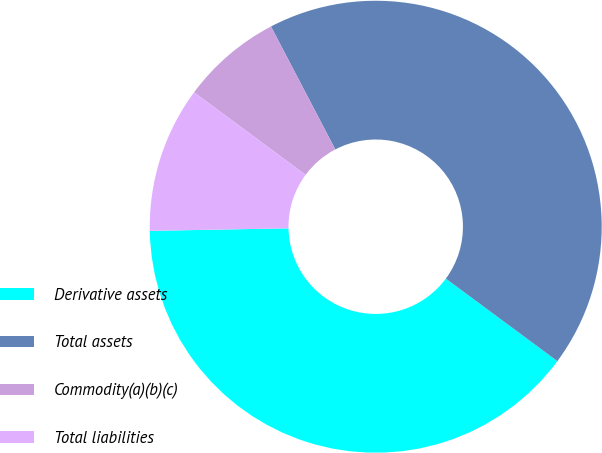Convert chart to OTSL. <chart><loc_0><loc_0><loc_500><loc_500><pie_chart><fcel>Derivative assets<fcel>Total assets<fcel>Commodity(a)(b)(c)<fcel>Total liabilities<nl><fcel>39.57%<fcel>42.81%<fcel>7.19%<fcel>10.43%<nl></chart> 